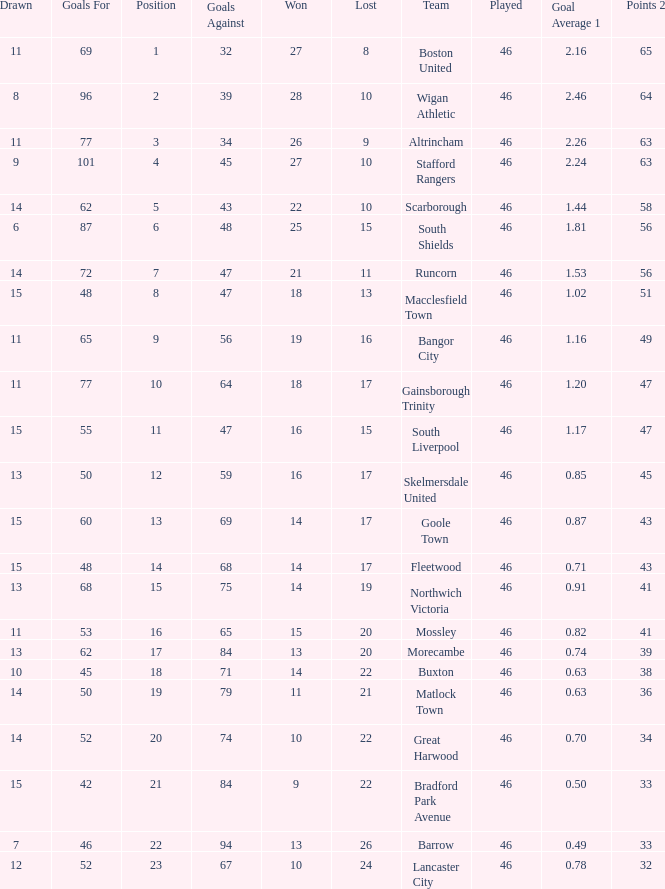How many games did the team who scored 60 goals win? 14.0. 